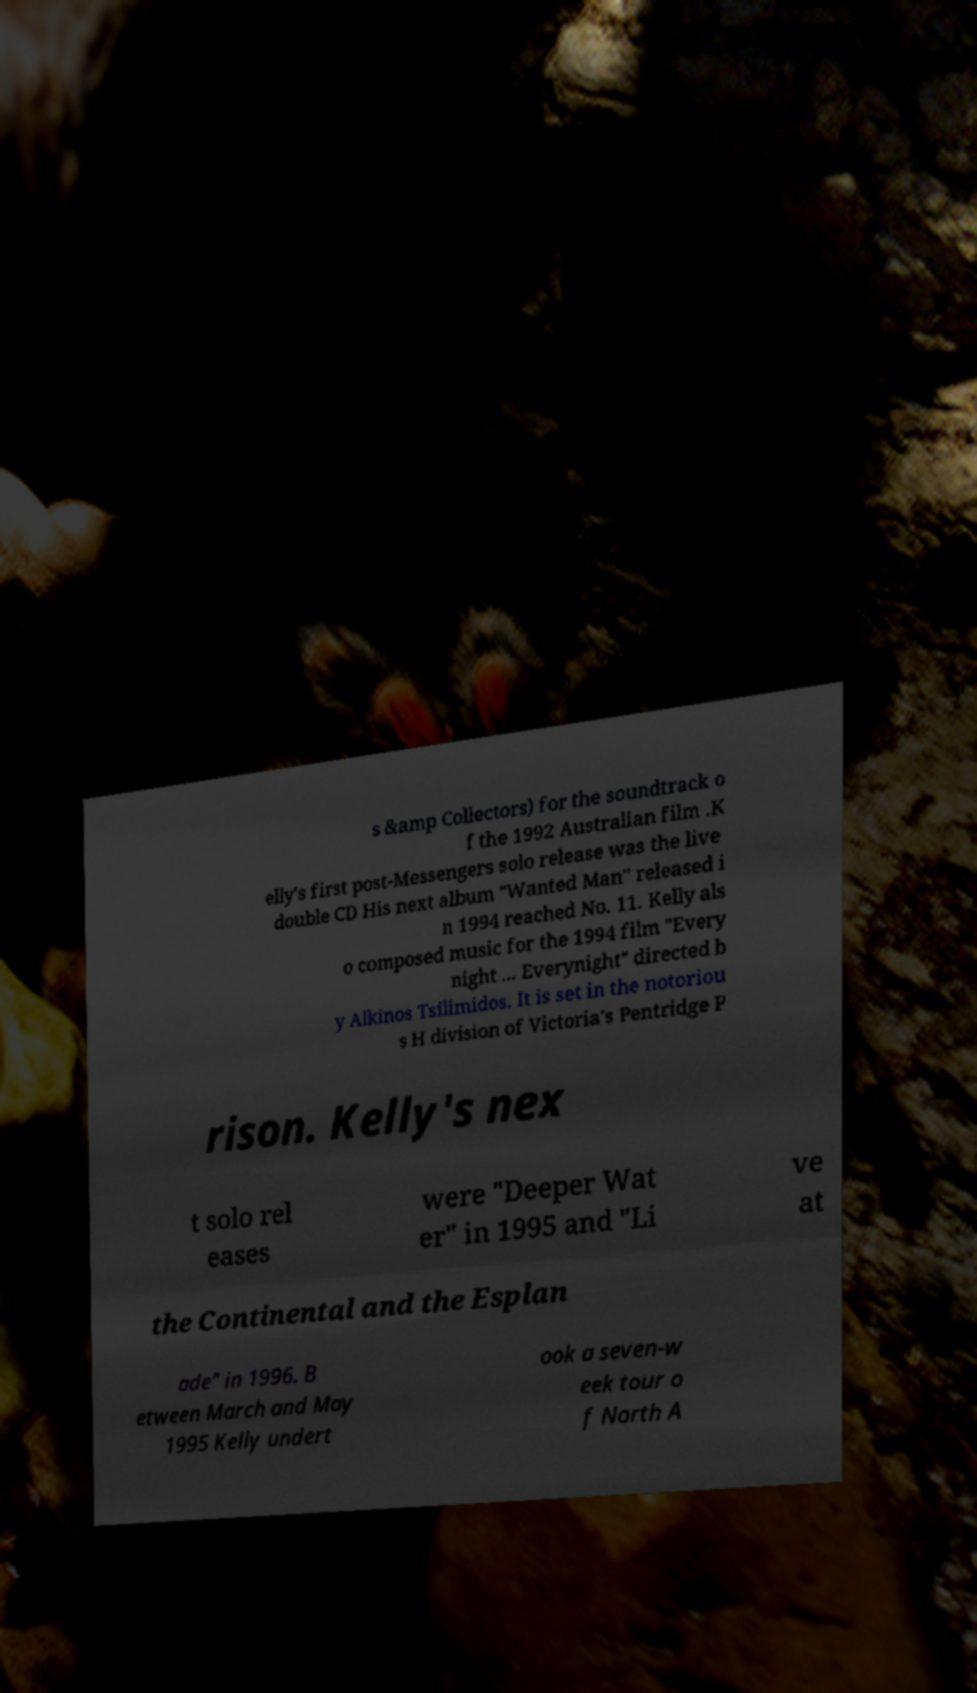Please identify and transcribe the text found in this image. s &amp Collectors) for the soundtrack o f the 1992 Australian film .K elly's first post-Messengers solo release was the live double CD His next album "Wanted Man" released i n 1994 reached No. 11. Kelly als o composed music for the 1994 film "Every night ... Everynight" directed b y Alkinos Tsilimidos. It is set in the notoriou s H division of Victoria's Pentridge P rison. Kelly's nex t solo rel eases were "Deeper Wat er" in 1995 and "Li ve at the Continental and the Esplan ade" in 1996. B etween March and May 1995 Kelly undert ook a seven-w eek tour o f North A 